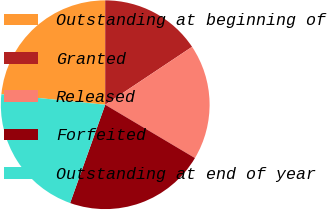Convert chart to OTSL. <chart><loc_0><loc_0><loc_500><loc_500><pie_chart><fcel>Outstanding at beginning of<fcel>Granted<fcel>Released<fcel>Forfeited<fcel>Outstanding at end of year<nl><fcel>23.4%<fcel>15.64%<fcel>17.89%<fcel>21.92%<fcel>21.14%<nl></chart> 